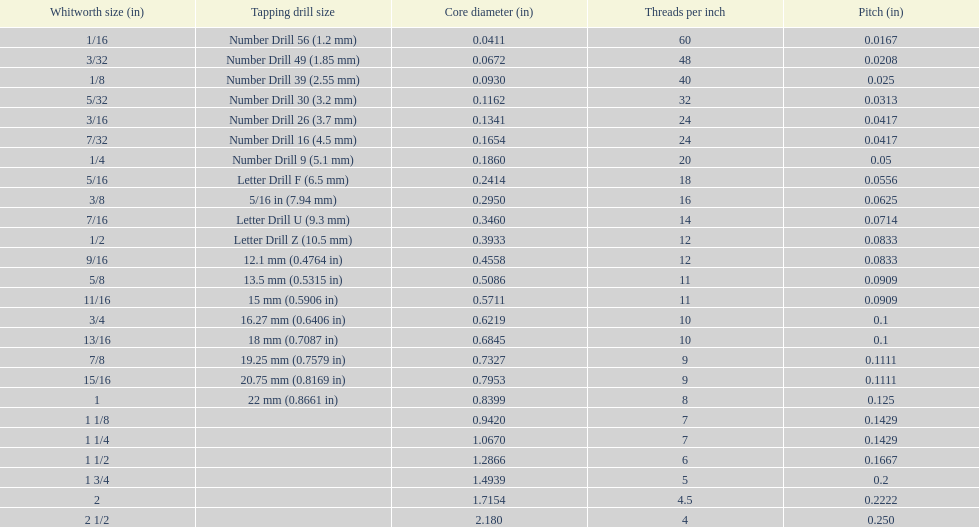What core diameter (in) comes after 0.0930? 0.1162. 